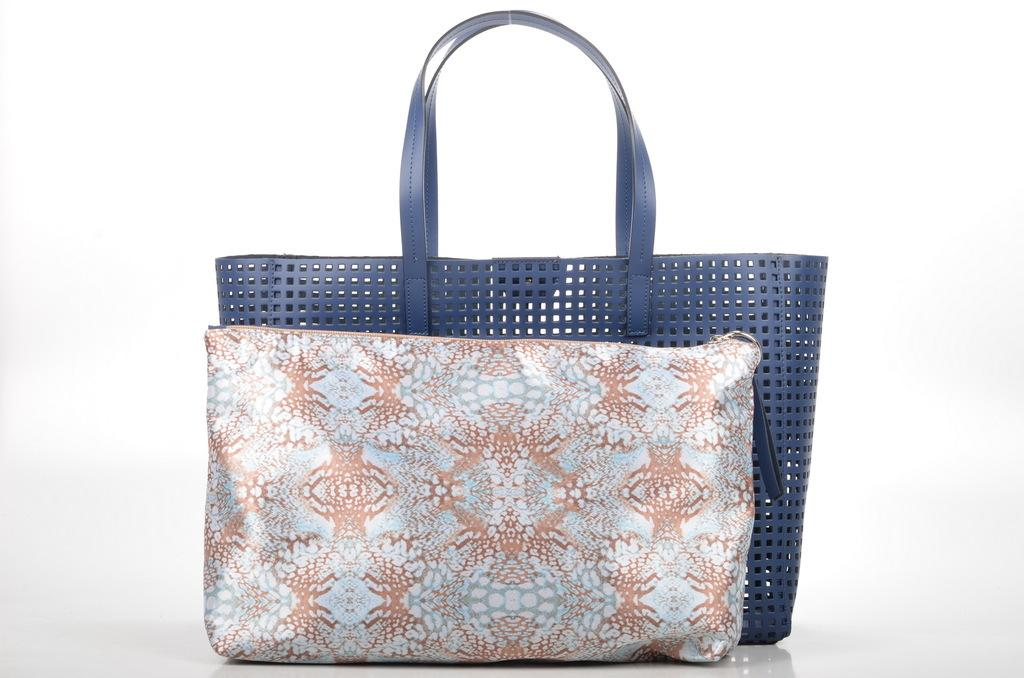What type of accessory is visible in the image? There is a handbag in the image. What other object can be seen in the image? There is a basket in the image. Is the queen holding the handbag in the image? A: There is no queen present in the image, and therefore she cannot be holding the handbag. 